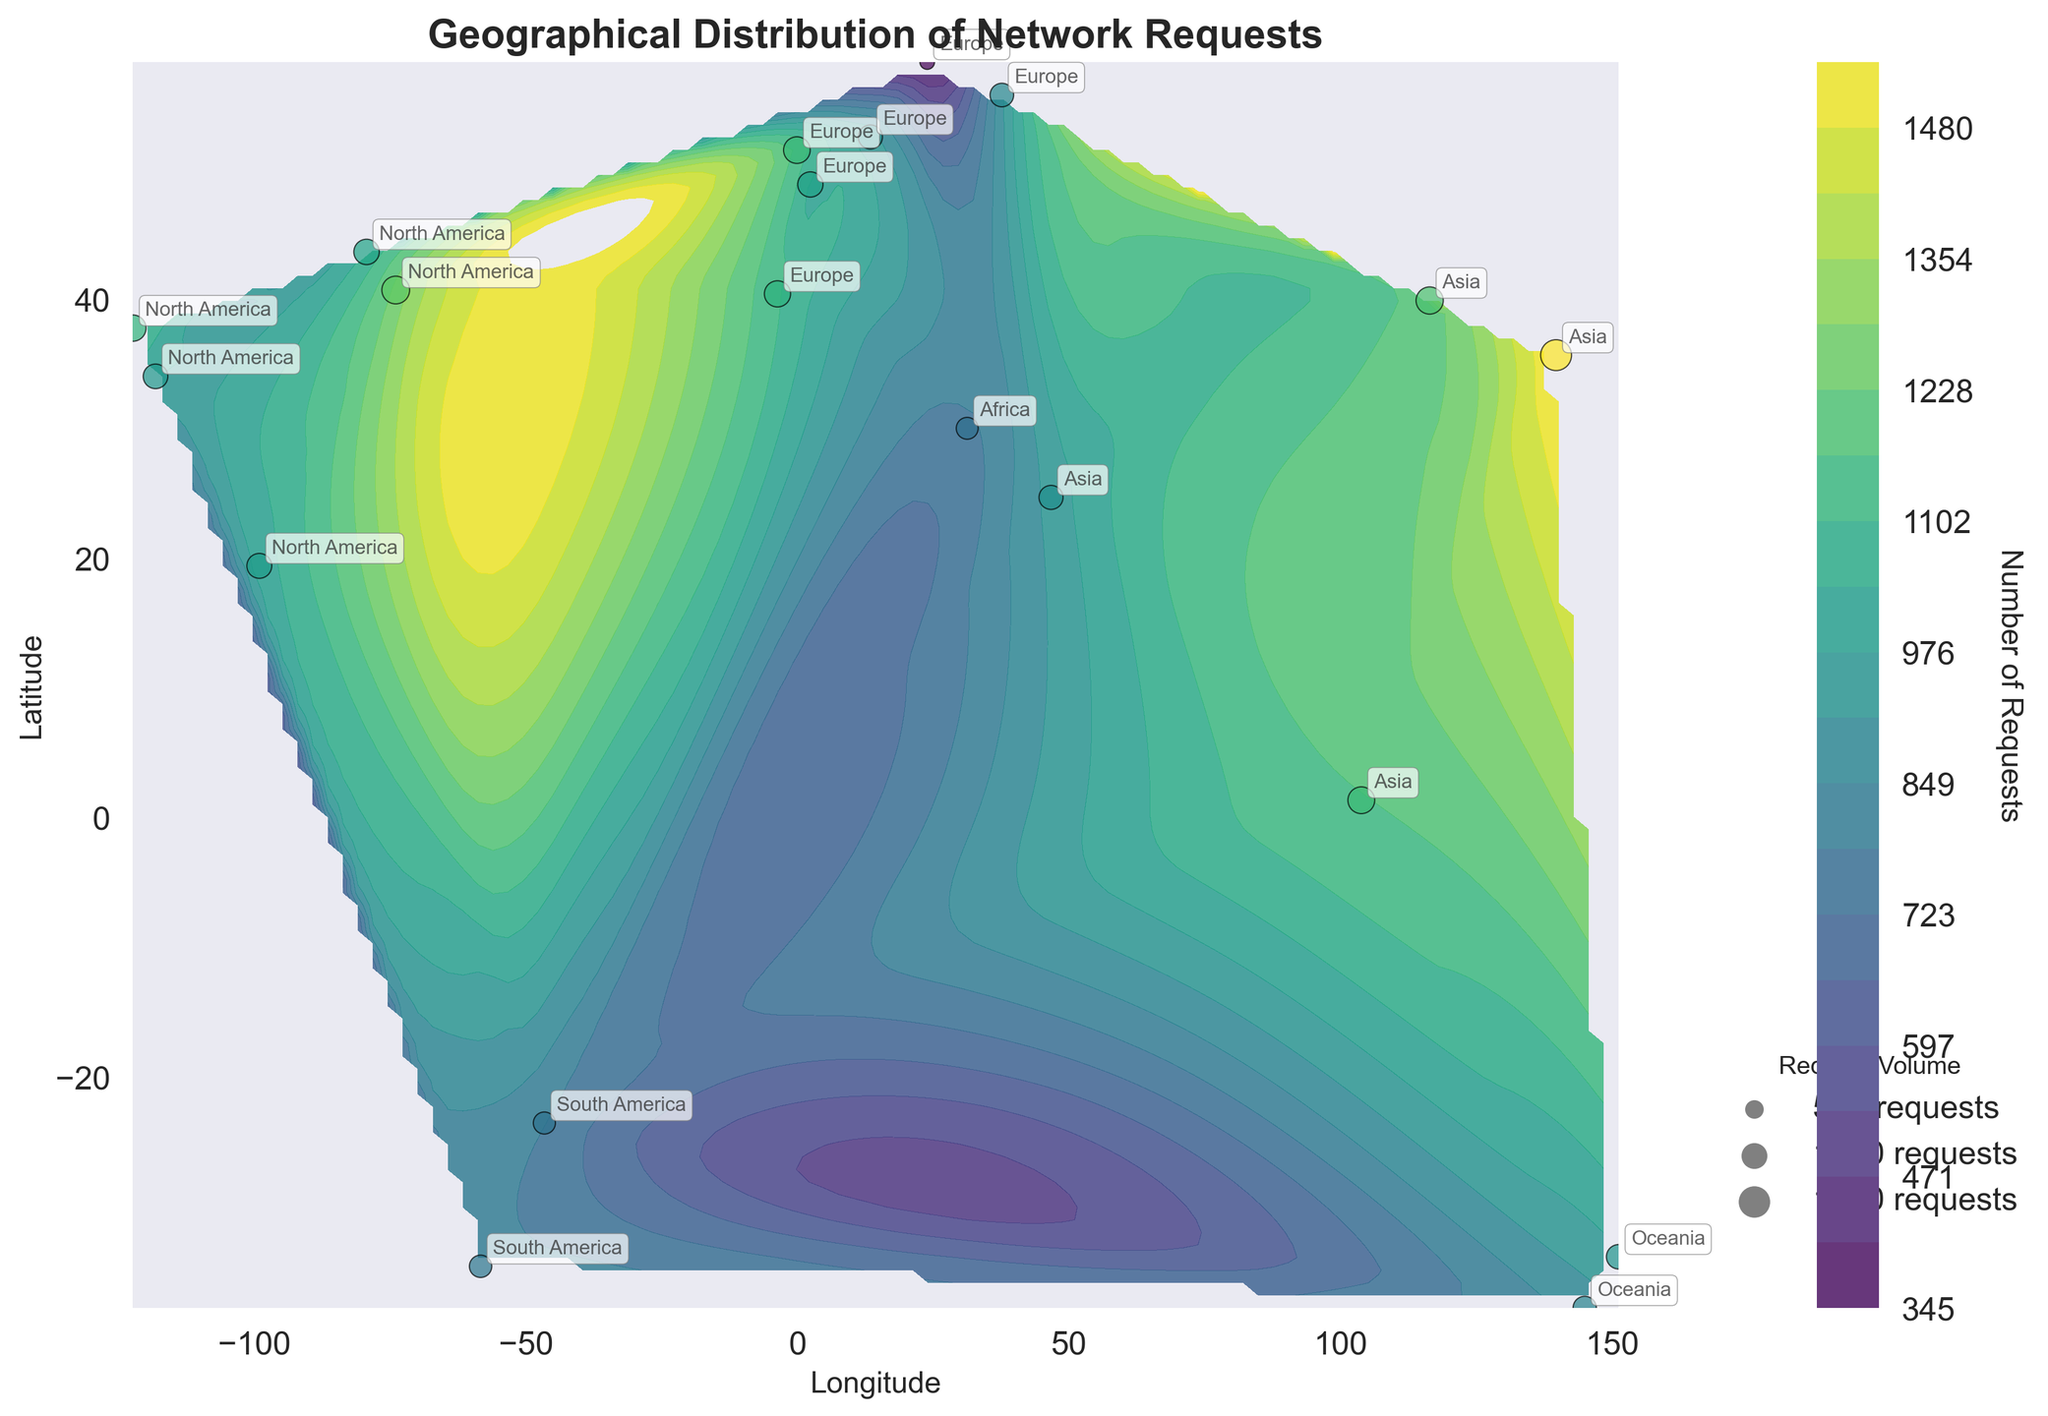what is the title of the figure? The title of the figure can be seen at the top, it reads 'Geographical Distribution of Network Requests'.
Answer: Geographical Distribution of Network Requests Which region has the highest number of requests? The figure allows us to see that Tokyo, Japan (Asia region) has the highest number of requests based on the dark color shades and the data annotations.
Answer: Asia How is the volume of requests depicted on the figure? The volume of requests is depicted using both color gradients in the contour plot and the size of the scatter plot points. Larger and darker points indicate higher request volumes.
Answer: Color gradients and point sizes What is the color indicating the highest and lowest request volumes? Darker colors indicate higher request volumes, while lighter colors indicate lower request volumes. This is evident from the color bar on the side.
Answer: Darker colors for highest, lighter colors for lowest How many requests were made in New York? By looking at the scatter plot annotations, we can see that New York (North America region) has 1245 requests.
Answer: 1245 Compare the number of requests between Berlin (Europe) and Cairo (Africa). Which city has more requests, and by how many? Berlin has 941 requests and Cairo has 775 requests. To find the difference, subtract 775 from 941, resulting in 166 more requests in Berlin.
Answer: Berlin, 166 more requests How are the regions identified on the plot? The regions are identified through annotations next to each scatter plot point, noting the region names like 'North America', 'Europe', 'Asia', etc.
Answer: Annotations Which color map is used in the contour plot? The contour plot uses the 'viridis' color map, as evidenced by the color gradient in the plot.
Answer: Viridis What does the color bar represent on the side of the figure? The color bar represents the number of requests. The label reads 'Number of Requests' and it shows the gradient of request volumes with respect to color intensity.
Answer: Number of Requests Which city has fewer requests, Mexico City or Singapore? Mexico City has 1003 requests and Singapore has 1162 requests, hence Mexico City has fewer requests.
Answer: Mexico City 